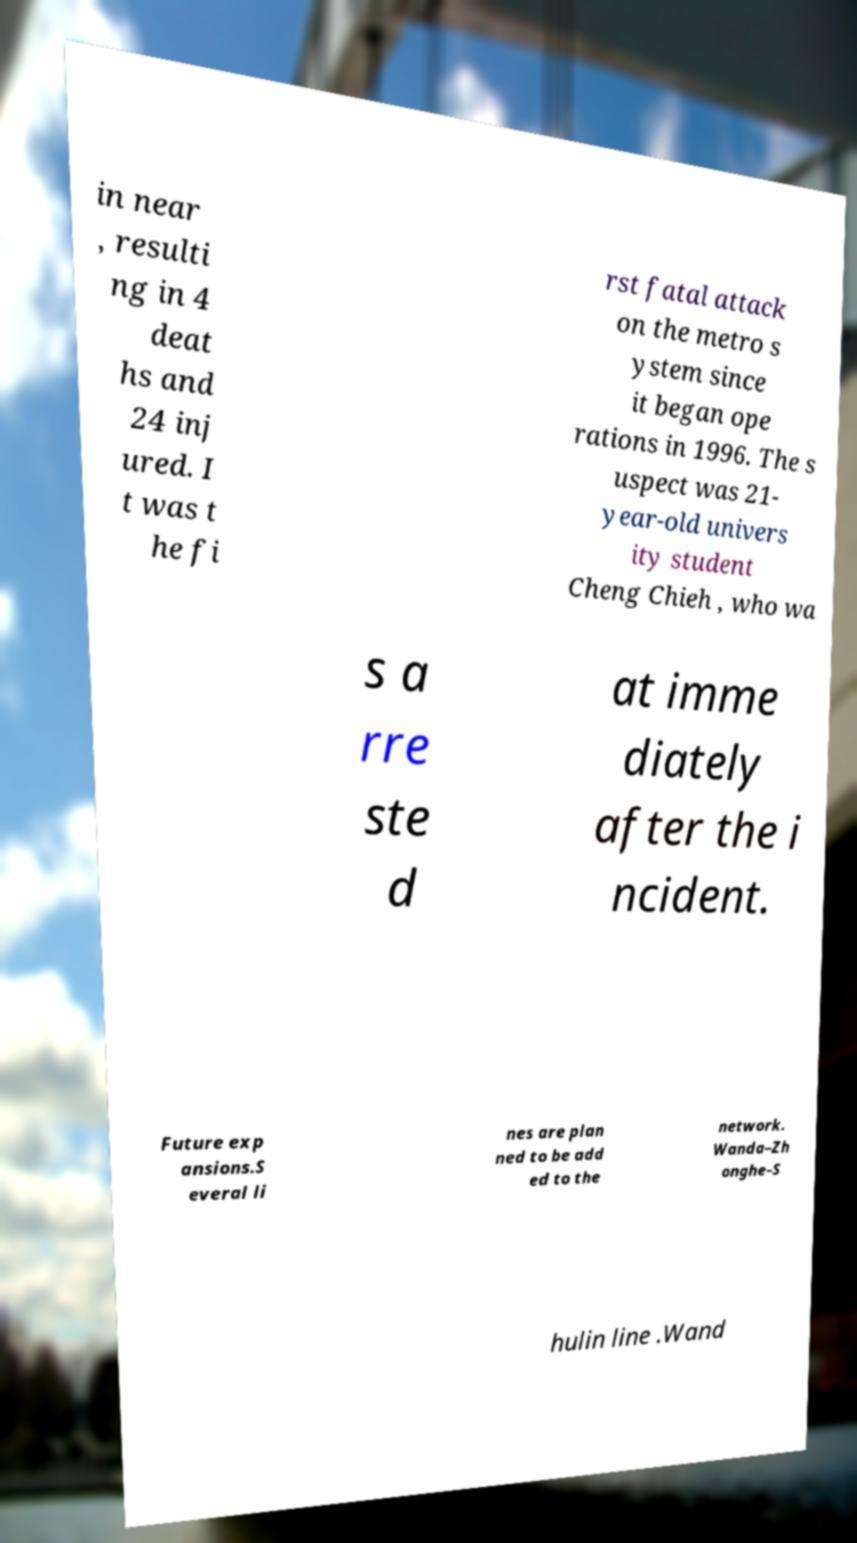There's text embedded in this image that I need extracted. Can you transcribe it verbatim? in near , resulti ng in 4 deat hs and 24 inj ured. I t was t he fi rst fatal attack on the metro s ystem since it began ope rations in 1996. The s uspect was 21- year-old univers ity student Cheng Chieh , who wa s a rre ste d at imme diately after the i ncident. Future exp ansions.S everal li nes are plan ned to be add ed to the network. Wanda–Zh onghe–S hulin line .Wand 